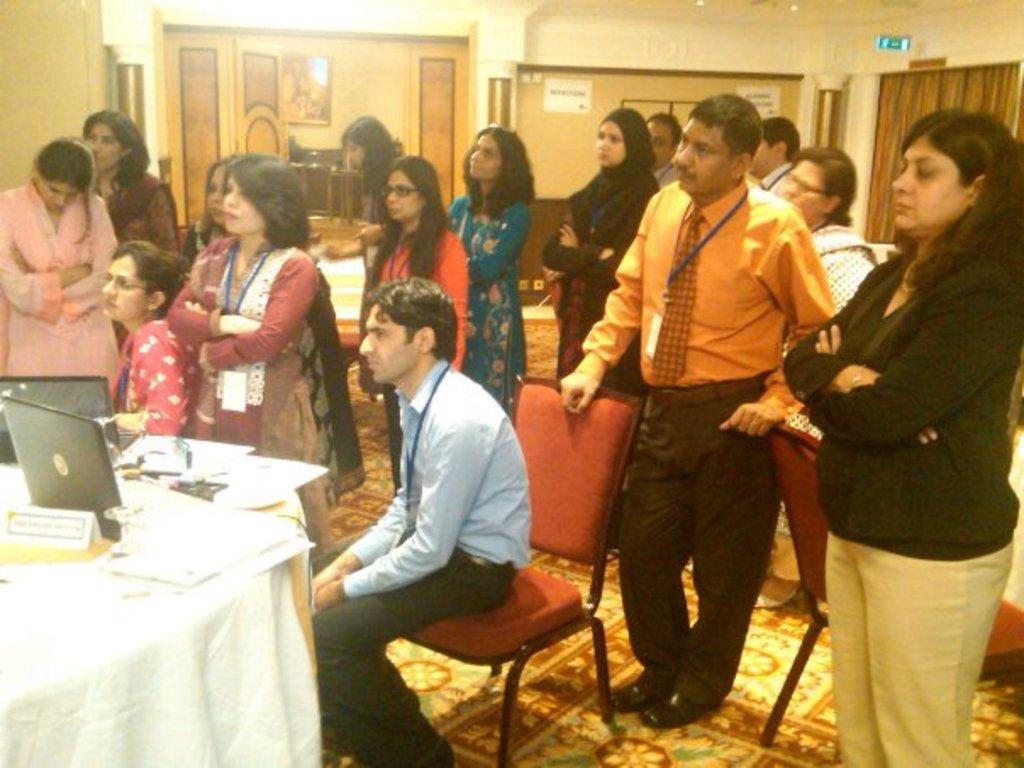What are the majority of the persons in the image doing? Most of the persons are standing. Are there any persons sitting in the image? Yes, two persons are sitting on chairs. What can be seen on the table in the image? There are papers and laptops on the table. What is hanging on the wall in the image? There is a picture on the wall. What type of window treatment is present in the image? There is a curtain in the image. What is covering the floor in the image? The floor has a carpet. What type of rice is being served in the image? There is no rice present in the image. What account is being discussed by the persons in the image? There is no account being discussed in the image; the conversation cannot be determined from the provided facts. 